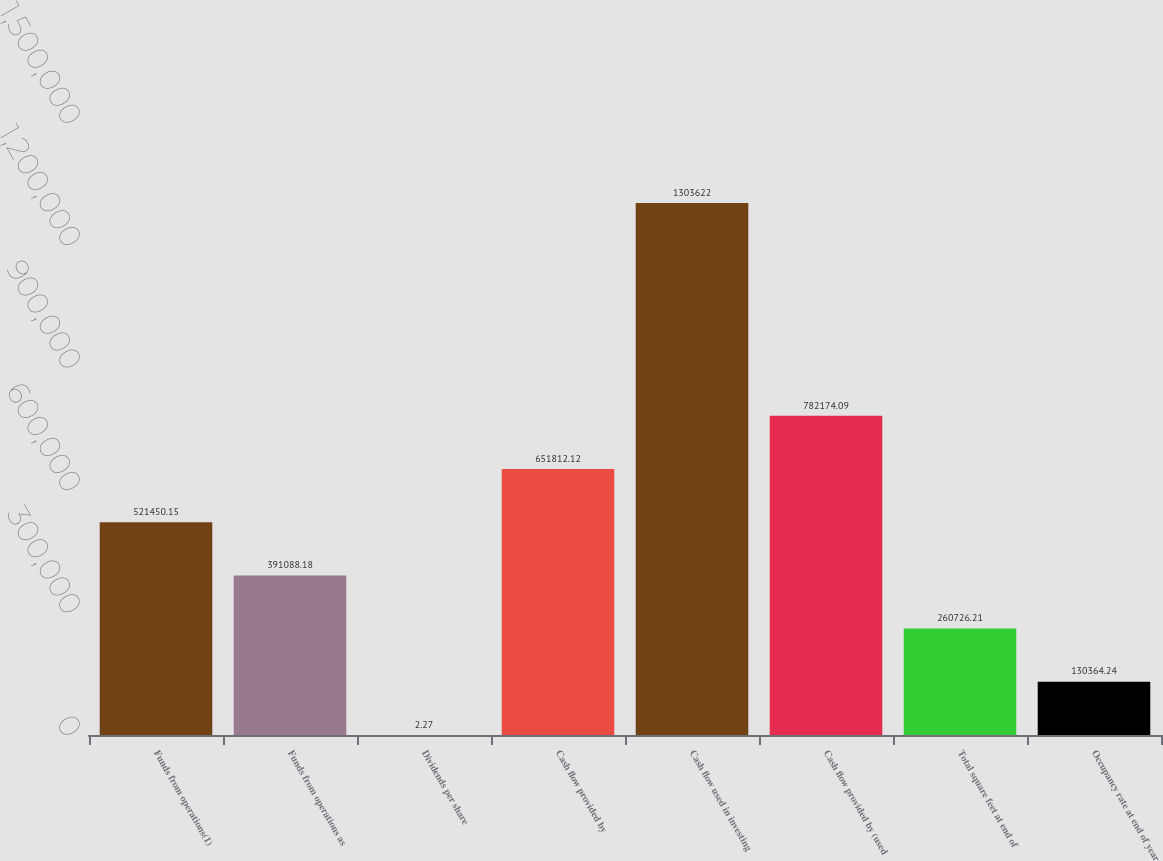Convert chart. <chart><loc_0><loc_0><loc_500><loc_500><bar_chart><fcel>Funds from operations(1)<fcel>Funds from operations as<fcel>Dividends per share<fcel>Cash flow provided by<fcel>Cash flow used in investing<fcel>Cash flow provided by (used<fcel>Total square feet at end of<fcel>Occupancy rate at end of year<nl><fcel>521450<fcel>391088<fcel>2.27<fcel>651812<fcel>1.30362e+06<fcel>782174<fcel>260726<fcel>130364<nl></chart> 